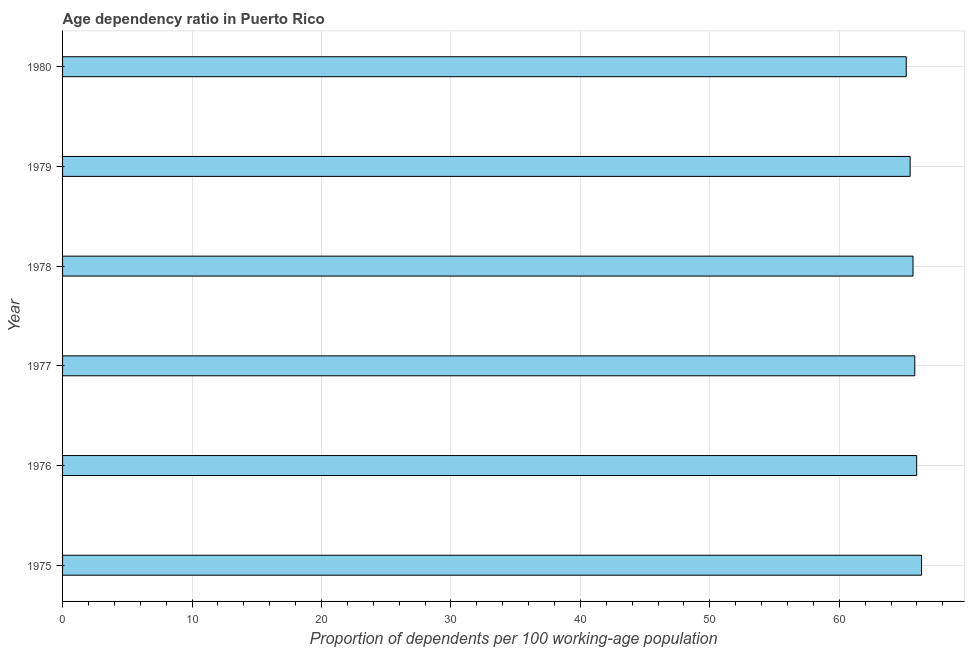Does the graph contain any zero values?
Your answer should be compact. No. What is the title of the graph?
Give a very brief answer. Age dependency ratio in Puerto Rico. What is the label or title of the X-axis?
Provide a succinct answer. Proportion of dependents per 100 working-age population. What is the label or title of the Y-axis?
Your response must be concise. Year. What is the age dependency ratio in 1977?
Offer a terse response. 65.83. Across all years, what is the maximum age dependency ratio?
Give a very brief answer. 66.35. Across all years, what is the minimum age dependency ratio?
Your answer should be compact. 65.17. In which year was the age dependency ratio maximum?
Provide a short and direct response. 1975. What is the sum of the age dependency ratio?
Offer a terse response. 394.5. What is the difference between the age dependency ratio in 1976 and 1977?
Provide a succinct answer. 0.15. What is the average age dependency ratio per year?
Your answer should be very brief. 65.75. What is the median age dependency ratio?
Keep it short and to the point. 65.76. In how many years, is the age dependency ratio greater than 50 ?
Offer a very short reply. 6. Do a majority of the years between 1980 and 1979 (inclusive) have age dependency ratio greater than 14 ?
Offer a terse response. No. Is the difference between the age dependency ratio in 1976 and 1980 greater than the difference between any two years?
Provide a succinct answer. No. What is the difference between the highest and the second highest age dependency ratio?
Make the answer very short. 0.37. Is the sum of the age dependency ratio in 1976 and 1979 greater than the maximum age dependency ratio across all years?
Your answer should be compact. Yes. What is the difference between the highest and the lowest age dependency ratio?
Offer a very short reply. 1.18. In how many years, is the age dependency ratio greater than the average age dependency ratio taken over all years?
Your response must be concise. 3. How many bars are there?
Keep it short and to the point. 6. What is the difference between two consecutive major ticks on the X-axis?
Ensure brevity in your answer.  10. Are the values on the major ticks of X-axis written in scientific E-notation?
Your answer should be very brief. No. What is the Proportion of dependents per 100 working-age population of 1975?
Offer a very short reply. 66.35. What is the Proportion of dependents per 100 working-age population of 1976?
Ensure brevity in your answer.  65.98. What is the Proportion of dependents per 100 working-age population of 1977?
Provide a short and direct response. 65.83. What is the Proportion of dependents per 100 working-age population of 1978?
Offer a very short reply. 65.69. What is the Proportion of dependents per 100 working-age population in 1979?
Your answer should be very brief. 65.47. What is the Proportion of dependents per 100 working-age population in 1980?
Keep it short and to the point. 65.17. What is the difference between the Proportion of dependents per 100 working-age population in 1975 and 1976?
Your answer should be very brief. 0.37. What is the difference between the Proportion of dependents per 100 working-age population in 1975 and 1977?
Your answer should be very brief. 0.52. What is the difference between the Proportion of dependents per 100 working-age population in 1975 and 1978?
Ensure brevity in your answer.  0.66. What is the difference between the Proportion of dependents per 100 working-age population in 1975 and 1979?
Provide a short and direct response. 0.88. What is the difference between the Proportion of dependents per 100 working-age population in 1975 and 1980?
Your response must be concise. 1.18. What is the difference between the Proportion of dependents per 100 working-age population in 1976 and 1977?
Your answer should be compact. 0.15. What is the difference between the Proportion of dependents per 100 working-age population in 1976 and 1978?
Your answer should be very brief. 0.29. What is the difference between the Proportion of dependents per 100 working-age population in 1976 and 1979?
Ensure brevity in your answer.  0.51. What is the difference between the Proportion of dependents per 100 working-age population in 1976 and 1980?
Offer a terse response. 0.81. What is the difference between the Proportion of dependents per 100 working-age population in 1977 and 1978?
Provide a short and direct response. 0.14. What is the difference between the Proportion of dependents per 100 working-age population in 1977 and 1979?
Your response must be concise. 0.36. What is the difference between the Proportion of dependents per 100 working-age population in 1977 and 1980?
Give a very brief answer. 0.66. What is the difference between the Proportion of dependents per 100 working-age population in 1978 and 1979?
Offer a very short reply. 0.22. What is the difference between the Proportion of dependents per 100 working-age population in 1978 and 1980?
Provide a short and direct response. 0.52. What is the difference between the Proportion of dependents per 100 working-age population in 1979 and 1980?
Ensure brevity in your answer.  0.3. What is the ratio of the Proportion of dependents per 100 working-age population in 1975 to that in 1976?
Keep it short and to the point. 1.01. What is the ratio of the Proportion of dependents per 100 working-age population in 1975 to that in 1978?
Ensure brevity in your answer.  1.01. What is the ratio of the Proportion of dependents per 100 working-age population in 1976 to that in 1978?
Your response must be concise. 1. What is the ratio of the Proportion of dependents per 100 working-age population in 1977 to that in 1979?
Offer a very short reply. 1. What is the ratio of the Proportion of dependents per 100 working-age population in 1978 to that in 1979?
Your answer should be compact. 1. 